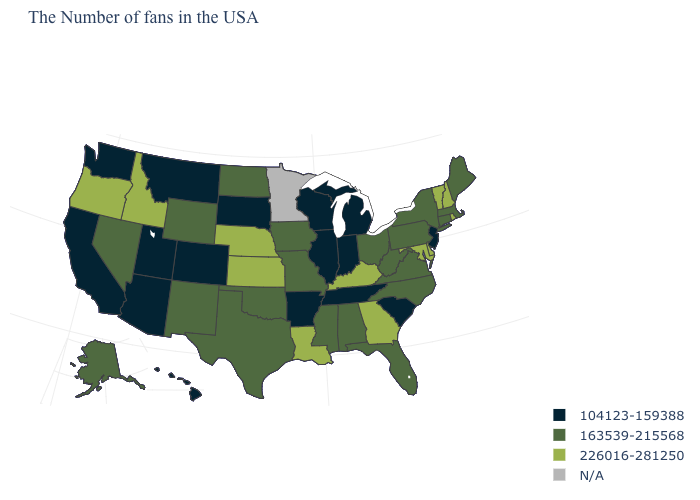What is the highest value in the USA?
Be succinct. 226016-281250. Which states hav the highest value in the West?
Write a very short answer. Idaho, Oregon. What is the value of Colorado?
Be succinct. 104123-159388. Name the states that have a value in the range 226016-281250?
Be succinct. Rhode Island, New Hampshire, Vermont, Delaware, Maryland, Georgia, Kentucky, Louisiana, Kansas, Nebraska, Idaho, Oregon. Among the states that border South Carolina , which have the lowest value?
Quick response, please. North Carolina. What is the highest value in the USA?
Be succinct. 226016-281250. What is the value of New Hampshire?
Be succinct. 226016-281250. Name the states that have a value in the range 104123-159388?
Be succinct. New Jersey, South Carolina, Michigan, Indiana, Tennessee, Wisconsin, Illinois, Arkansas, South Dakota, Colorado, Utah, Montana, Arizona, California, Washington, Hawaii. Does the first symbol in the legend represent the smallest category?
Give a very brief answer. Yes. Which states have the lowest value in the Northeast?
Answer briefly. New Jersey. Name the states that have a value in the range 163539-215568?
Concise answer only. Maine, Massachusetts, Connecticut, New York, Pennsylvania, Virginia, North Carolina, West Virginia, Ohio, Florida, Alabama, Mississippi, Missouri, Iowa, Oklahoma, Texas, North Dakota, Wyoming, New Mexico, Nevada, Alaska. Which states have the highest value in the USA?
Concise answer only. Rhode Island, New Hampshire, Vermont, Delaware, Maryland, Georgia, Kentucky, Louisiana, Kansas, Nebraska, Idaho, Oregon. What is the value of Missouri?
Short answer required. 163539-215568. What is the value of Montana?
Answer briefly. 104123-159388. 